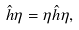Convert formula to latex. <formula><loc_0><loc_0><loc_500><loc_500>\hat { h } \eta = \eta \hat { h } \eta ,</formula> 